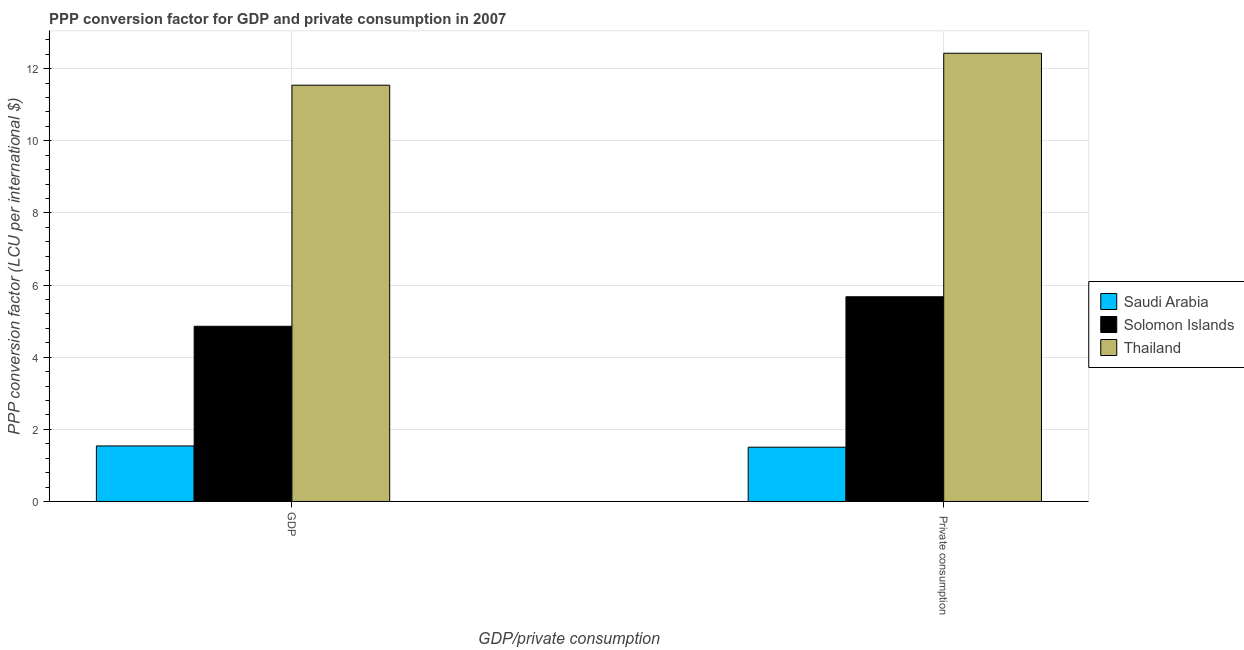How many groups of bars are there?
Provide a succinct answer. 2. Are the number of bars per tick equal to the number of legend labels?
Provide a succinct answer. Yes. How many bars are there on the 2nd tick from the left?
Your response must be concise. 3. What is the label of the 2nd group of bars from the left?
Give a very brief answer.  Private consumption. What is the ppp conversion factor for private consumption in Thailand?
Your answer should be very brief. 12.43. Across all countries, what is the maximum ppp conversion factor for private consumption?
Make the answer very short. 12.43. Across all countries, what is the minimum ppp conversion factor for gdp?
Offer a very short reply. 1.54. In which country was the ppp conversion factor for gdp maximum?
Offer a terse response. Thailand. In which country was the ppp conversion factor for gdp minimum?
Your answer should be very brief. Saudi Arabia. What is the total ppp conversion factor for private consumption in the graph?
Your answer should be compact. 19.61. What is the difference between the ppp conversion factor for gdp in Solomon Islands and that in Saudi Arabia?
Make the answer very short. 3.32. What is the difference between the ppp conversion factor for gdp in Solomon Islands and the ppp conversion factor for private consumption in Saudi Arabia?
Your answer should be very brief. 3.35. What is the average ppp conversion factor for gdp per country?
Offer a terse response. 5.98. What is the difference between the ppp conversion factor for private consumption and ppp conversion factor for gdp in Saudi Arabia?
Your response must be concise. -0.03. What is the ratio of the ppp conversion factor for private consumption in Solomon Islands to that in Thailand?
Provide a succinct answer. 0.46. In how many countries, is the ppp conversion factor for gdp greater than the average ppp conversion factor for gdp taken over all countries?
Keep it short and to the point. 1. What does the 3rd bar from the left in  Private consumption represents?
Provide a succinct answer. Thailand. What does the 1st bar from the right in  Private consumption represents?
Offer a very short reply. Thailand. What is the difference between two consecutive major ticks on the Y-axis?
Offer a terse response. 2. Are the values on the major ticks of Y-axis written in scientific E-notation?
Your answer should be compact. No. Where does the legend appear in the graph?
Your answer should be very brief. Center right. What is the title of the graph?
Offer a very short reply. PPP conversion factor for GDP and private consumption in 2007. What is the label or title of the X-axis?
Ensure brevity in your answer.  GDP/private consumption. What is the label or title of the Y-axis?
Provide a short and direct response. PPP conversion factor (LCU per international $). What is the PPP conversion factor (LCU per international $) of Saudi Arabia in GDP?
Give a very brief answer. 1.54. What is the PPP conversion factor (LCU per international $) in Solomon Islands in GDP?
Provide a succinct answer. 4.86. What is the PPP conversion factor (LCU per international $) of Thailand in GDP?
Offer a terse response. 11.54. What is the PPP conversion factor (LCU per international $) in Saudi Arabia in  Private consumption?
Provide a succinct answer. 1.51. What is the PPP conversion factor (LCU per international $) of Solomon Islands in  Private consumption?
Your answer should be very brief. 5.68. What is the PPP conversion factor (LCU per international $) of Thailand in  Private consumption?
Offer a very short reply. 12.43. Across all GDP/private consumption, what is the maximum PPP conversion factor (LCU per international $) in Saudi Arabia?
Provide a succinct answer. 1.54. Across all GDP/private consumption, what is the maximum PPP conversion factor (LCU per international $) of Solomon Islands?
Make the answer very short. 5.68. Across all GDP/private consumption, what is the maximum PPP conversion factor (LCU per international $) in Thailand?
Keep it short and to the point. 12.43. Across all GDP/private consumption, what is the minimum PPP conversion factor (LCU per international $) of Saudi Arabia?
Give a very brief answer. 1.51. Across all GDP/private consumption, what is the minimum PPP conversion factor (LCU per international $) of Solomon Islands?
Your response must be concise. 4.86. Across all GDP/private consumption, what is the minimum PPP conversion factor (LCU per international $) in Thailand?
Make the answer very short. 11.54. What is the total PPP conversion factor (LCU per international $) in Saudi Arabia in the graph?
Provide a succinct answer. 3.04. What is the total PPP conversion factor (LCU per international $) in Solomon Islands in the graph?
Make the answer very short. 10.53. What is the total PPP conversion factor (LCU per international $) in Thailand in the graph?
Keep it short and to the point. 23.97. What is the difference between the PPP conversion factor (LCU per international $) of Saudi Arabia in GDP and that in  Private consumption?
Offer a terse response. 0.03. What is the difference between the PPP conversion factor (LCU per international $) in Solomon Islands in GDP and that in  Private consumption?
Provide a succinct answer. -0.82. What is the difference between the PPP conversion factor (LCU per international $) in Thailand in GDP and that in  Private consumption?
Offer a terse response. -0.89. What is the difference between the PPP conversion factor (LCU per international $) in Saudi Arabia in GDP and the PPP conversion factor (LCU per international $) in Solomon Islands in  Private consumption?
Make the answer very short. -4.14. What is the difference between the PPP conversion factor (LCU per international $) of Saudi Arabia in GDP and the PPP conversion factor (LCU per international $) of Thailand in  Private consumption?
Provide a short and direct response. -10.89. What is the difference between the PPP conversion factor (LCU per international $) in Solomon Islands in GDP and the PPP conversion factor (LCU per international $) in Thailand in  Private consumption?
Keep it short and to the point. -7.57. What is the average PPP conversion factor (LCU per international $) in Saudi Arabia per GDP/private consumption?
Provide a succinct answer. 1.52. What is the average PPP conversion factor (LCU per international $) of Solomon Islands per GDP/private consumption?
Your response must be concise. 5.27. What is the average PPP conversion factor (LCU per international $) in Thailand per GDP/private consumption?
Give a very brief answer. 11.99. What is the difference between the PPP conversion factor (LCU per international $) in Saudi Arabia and PPP conversion factor (LCU per international $) in Solomon Islands in GDP?
Offer a very short reply. -3.32. What is the difference between the PPP conversion factor (LCU per international $) of Saudi Arabia and PPP conversion factor (LCU per international $) of Thailand in GDP?
Provide a short and direct response. -10. What is the difference between the PPP conversion factor (LCU per international $) of Solomon Islands and PPP conversion factor (LCU per international $) of Thailand in GDP?
Give a very brief answer. -6.68. What is the difference between the PPP conversion factor (LCU per international $) in Saudi Arabia and PPP conversion factor (LCU per international $) in Solomon Islands in  Private consumption?
Provide a short and direct response. -4.17. What is the difference between the PPP conversion factor (LCU per international $) of Saudi Arabia and PPP conversion factor (LCU per international $) of Thailand in  Private consumption?
Ensure brevity in your answer.  -10.92. What is the difference between the PPP conversion factor (LCU per international $) in Solomon Islands and PPP conversion factor (LCU per international $) in Thailand in  Private consumption?
Your answer should be very brief. -6.75. What is the ratio of the PPP conversion factor (LCU per international $) in Solomon Islands in GDP to that in  Private consumption?
Ensure brevity in your answer.  0.86. What is the ratio of the PPP conversion factor (LCU per international $) in Thailand in GDP to that in  Private consumption?
Make the answer very short. 0.93. What is the difference between the highest and the second highest PPP conversion factor (LCU per international $) of Saudi Arabia?
Your answer should be very brief. 0.03. What is the difference between the highest and the second highest PPP conversion factor (LCU per international $) in Solomon Islands?
Your answer should be very brief. 0.82. What is the difference between the highest and the second highest PPP conversion factor (LCU per international $) of Thailand?
Give a very brief answer. 0.89. What is the difference between the highest and the lowest PPP conversion factor (LCU per international $) of Saudi Arabia?
Your response must be concise. 0.03. What is the difference between the highest and the lowest PPP conversion factor (LCU per international $) in Solomon Islands?
Your answer should be very brief. 0.82. What is the difference between the highest and the lowest PPP conversion factor (LCU per international $) in Thailand?
Provide a succinct answer. 0.89. 